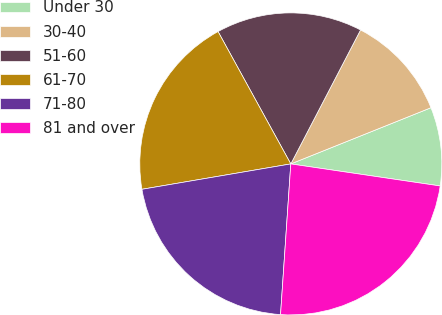Convert chart to OTSL. <chart><loc_0><loc_0><loc_500><loc_500><pie_chart><fcel>Under 30<fcel>30-40<fcel>51-60<fcel>61-70<fcel>71-80<fcel>81 and over<nl><fcel>8.4%<fcel>11.29%<fcel>15.64%<fcel>19.69%<fcel>21.23%<fcel>23.75%<nl></chart> 